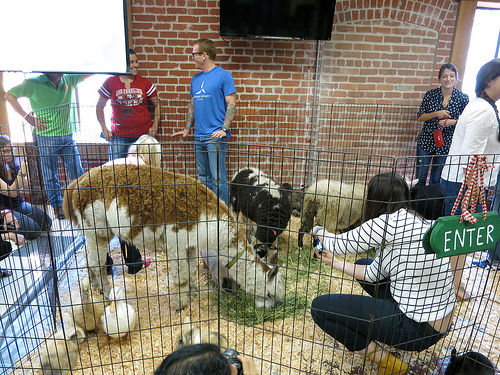<image>
Is there a llama in the fence? Yes. The llama is contained within or inside the fence, showing a containment relationship. 